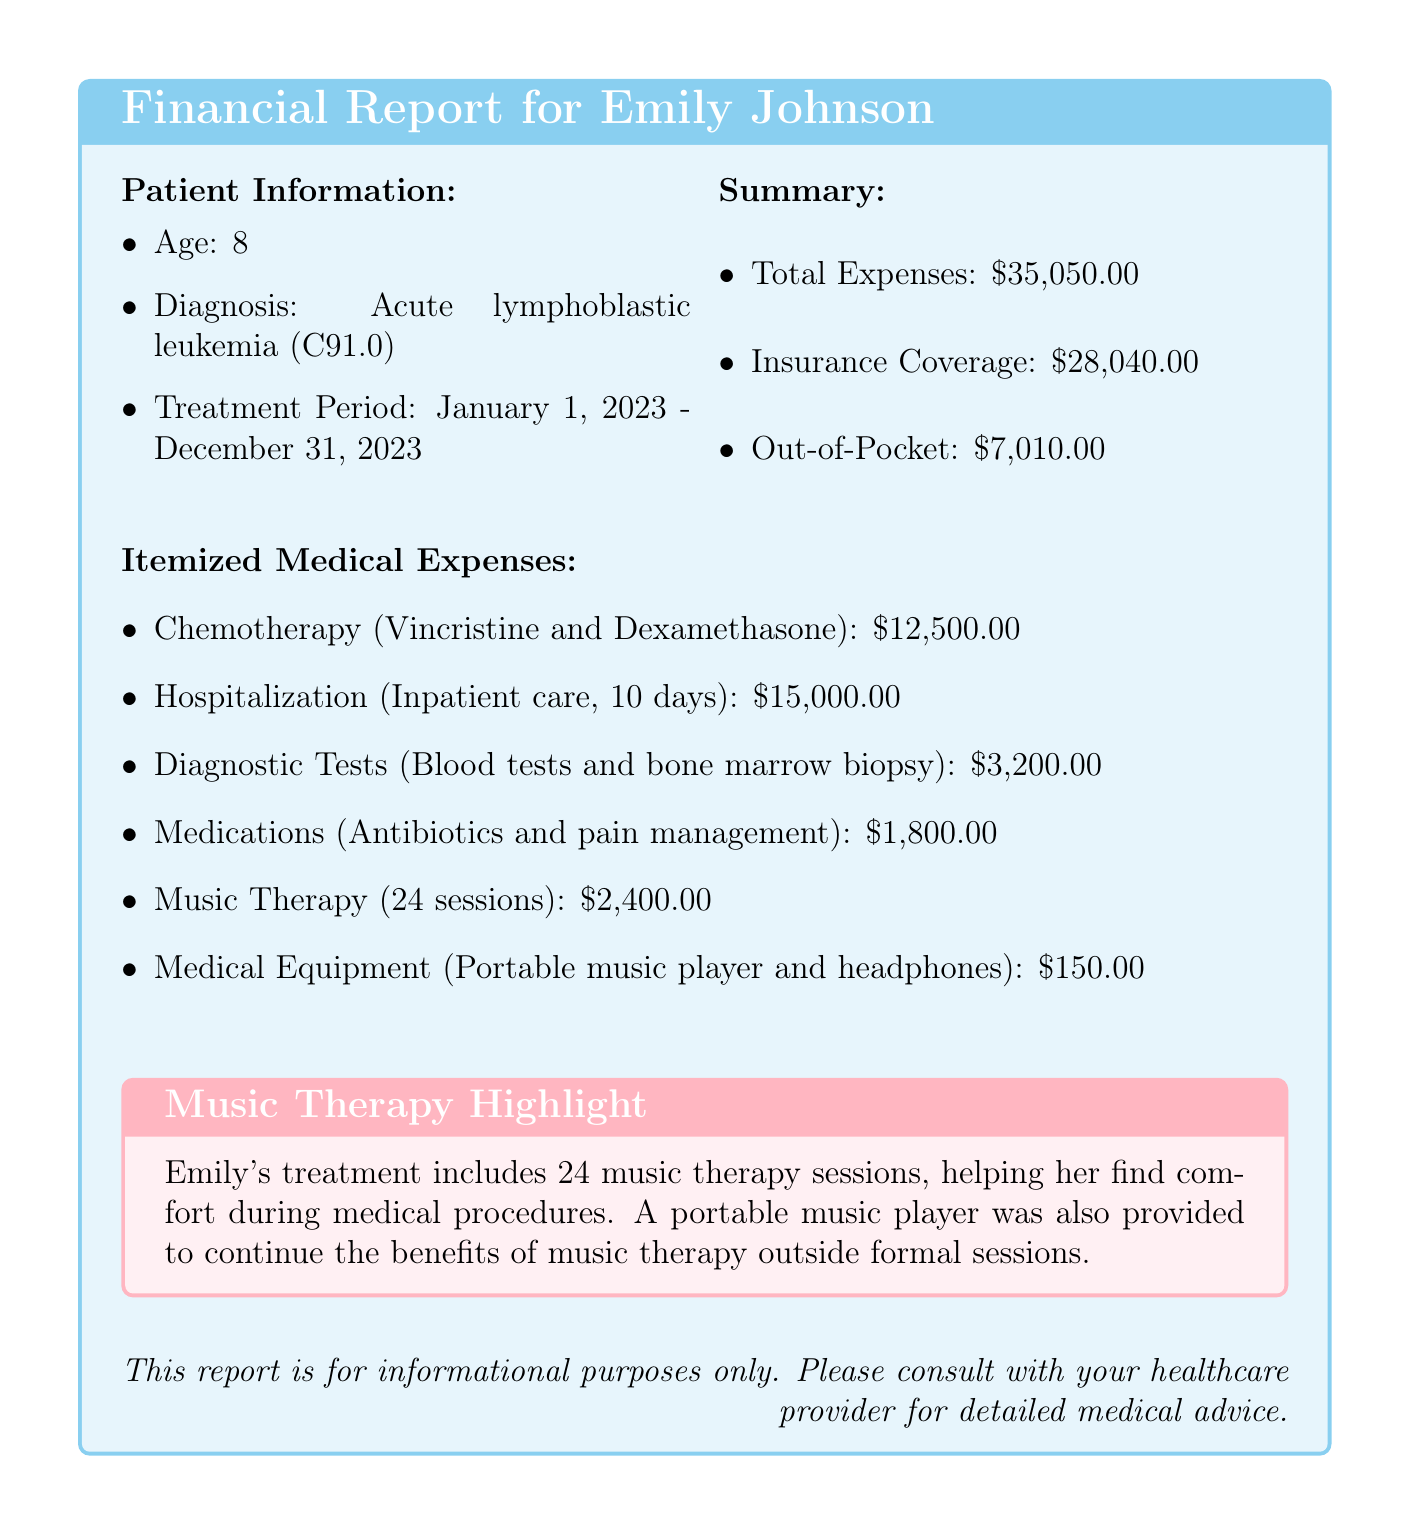what is the patient's name? The patient's name is listed at the top of the document under patient information.
Answer: Emily Johnson what is the age of the patient? The age of the patient is included in the patient information section.
Answer: 8 what is the total medical expense? The total medical expense is provided in the summary section of the document.
Answer: $35,050.00 how many music therapy sessions were included? The number of music therapy sessions is stated in the itemized medical expenses section.
Answer: 24 what is the cost of hospitalization? The cost of hospitalization is found in the itemized medical expenses list.
Answer: $15,000.00 what is the out-of-pocket expense for the patient? The out-of-pocket expense is indicated in the summary section of the document.
Answer: $7,010.00 what type of therapy is highlighted in the document? The type of therapy highlighted in the document is specified in the music therapy highlight box.
Answer: Music Therapy how much did insurance cover? The amount covered by insurance is summarized in the report.
Answer: $28,040.00 what medical equipment was provided? The specific medical equipment provided is described in the itemized medical expenses section.
Answer: Portable music player and headphones 